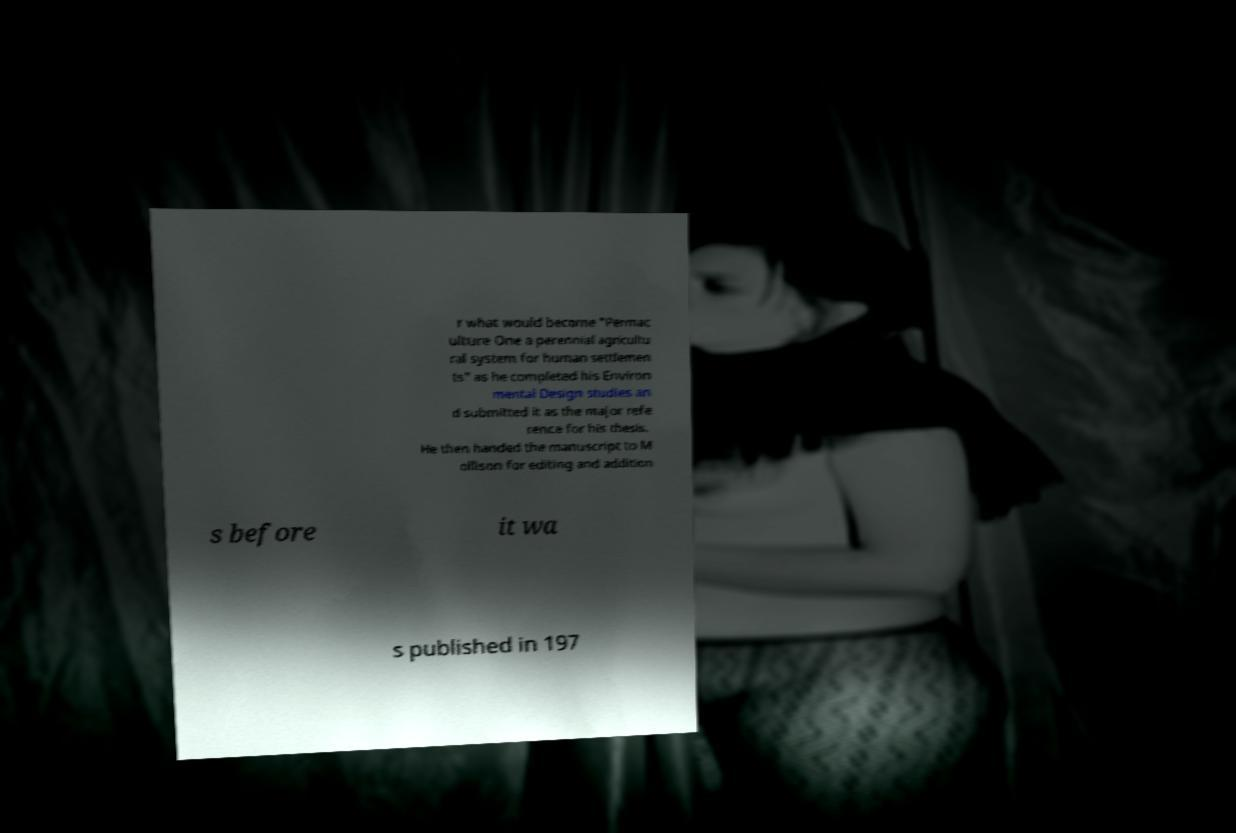Can you accurately transcribe the text from the provided image for me? r what would become "Permac ulture One a perennial agricultu ral system for human settlemen ts" as he completed his Environ mental Design studies an d submitted it as the major refe rence for his thesis. He then handed the manuscript to M ollison for editing and addition s before it wa s published in 197 